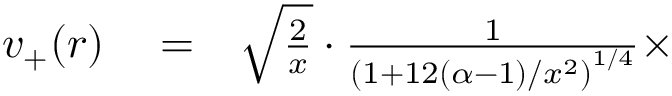<formula> <loc_0><loc_0><loc_500><loc_500>\begin{array} { r l r } { v _ { + } ( r ) } & = } & { \sqrt { \frac { 2 } { x } } \cdot \frac { 1 } { \left ( 1 + 1 2 ( \alpha - 1 ) / x ^ { 2 } \right ) ^ { 1 / 4 } } \times } \end{array}</formula> 